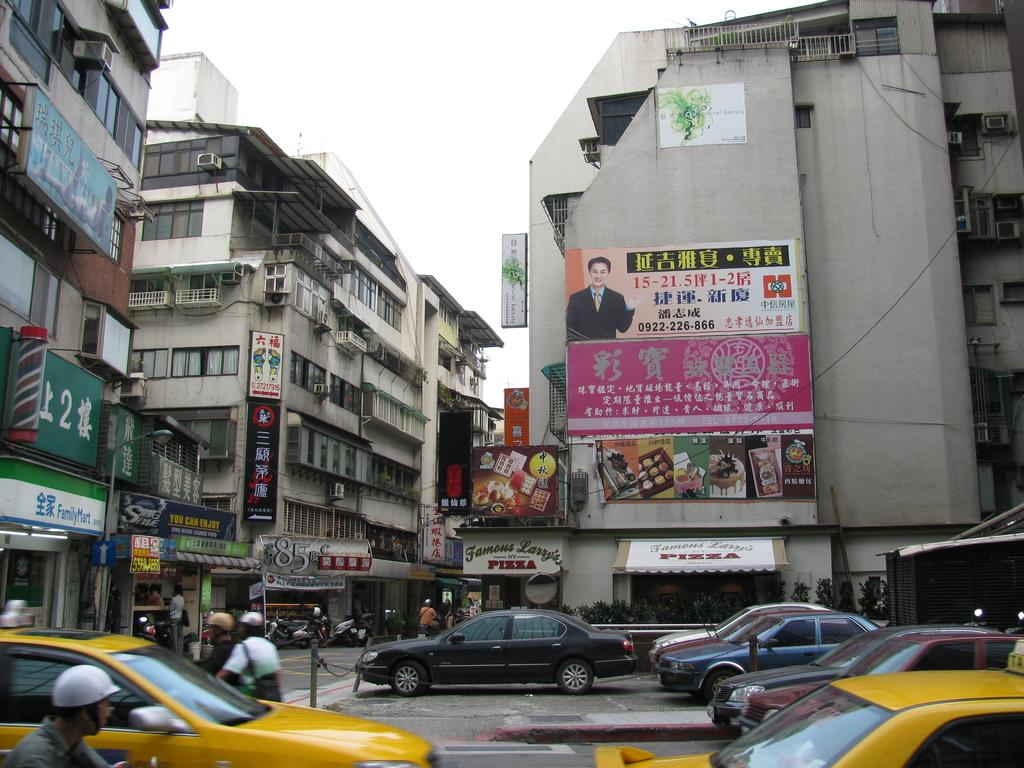<image>
Write a terse but informative summary of the picture. A busy street with a billboard that is in Chinese with the numbers 0922-226-866 on it 